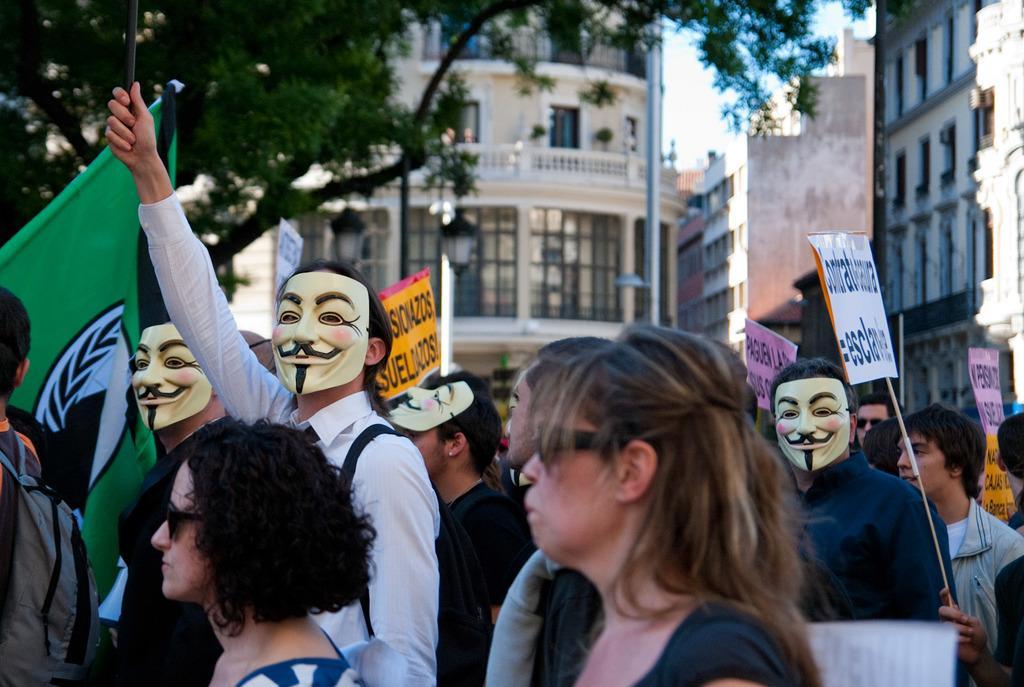Describe this image in one or two sentences. This picture shows a group of people protesting with the placards in their hands and a person standing with a mask on this face and we can see a building and trees 